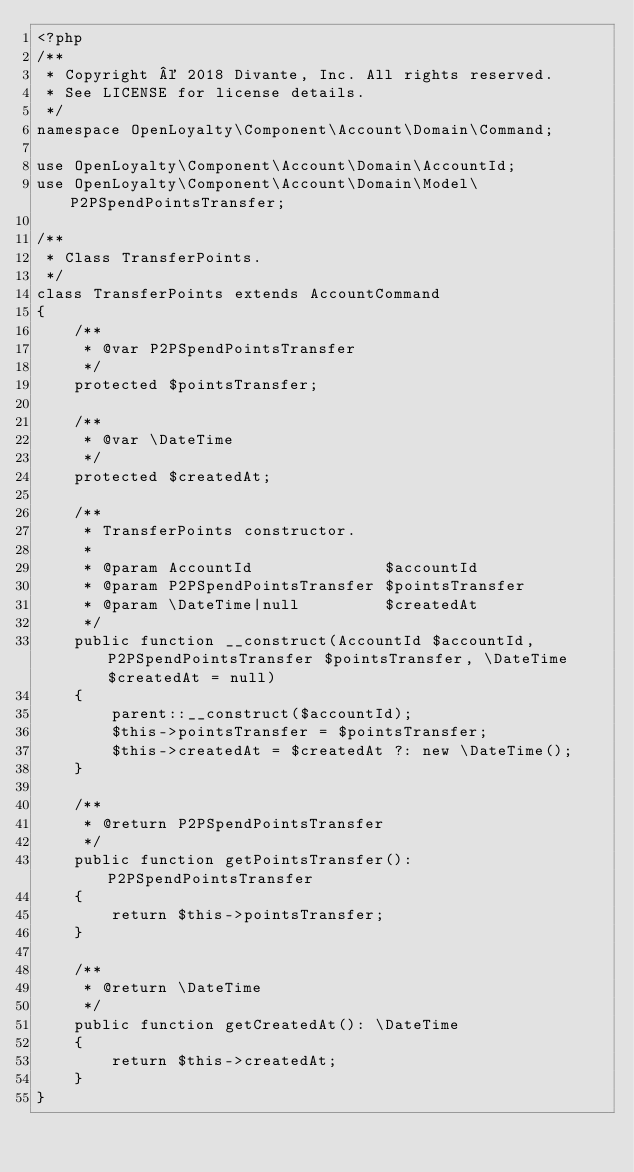<code> <loc_0><loc_0><loc_500><loc_500><_PHP_><?php
/**
 * Copyright © 2018 Divante, Inc. All rights reserved.
 * See LICENSE for license details.
 */
namespace OpenLoyalty\Component\Account\Domain\Command;

use OpenLoyalty\Component\Account\Domain\AccountId;
use OpenLoyalty\Component\Account\Domain\Model\P2PSpendPointsTransfer;

/**
 * Class TransferPoints.
 */
class TransferPoints extends AccountCommand
{
    /**
     * @var P2PSpendPointsTransfer
     */
    protected $pointsTransfer;

    /**
     * @var \DateTime
     */
    protected $createdAt;

    /**
     * TransferPoints constructor.
     *
     * @param AccountId              $accountId
     * @param P2PSpendPointsTransfer $pointsTransfer
     * @param \DateTime|null         $createdAt
     */
    public function __construct(AccountId $accountId, P2PSpendPointsTransfer $pointsTransfer, \DateTime $createdAt = null)
    {
        parent::__construct($accountId);
        $this->pointsTransfer = $pointsTransfer;
        $this->createdAt = $createdAt ?: new \DateTime();
    }

    /**
     * @return P2PSpendPointsTransfer
     */
    public function getPointsTransfer(): P2PSpendPointsTransfer
    {
        return $this->pointsTransfer;
    }

    /**
     * @return \DateTime
     */
    public function getCreatedAt(): \DateTime
    {
        return $this->createdAt;
    }
}
</code> 